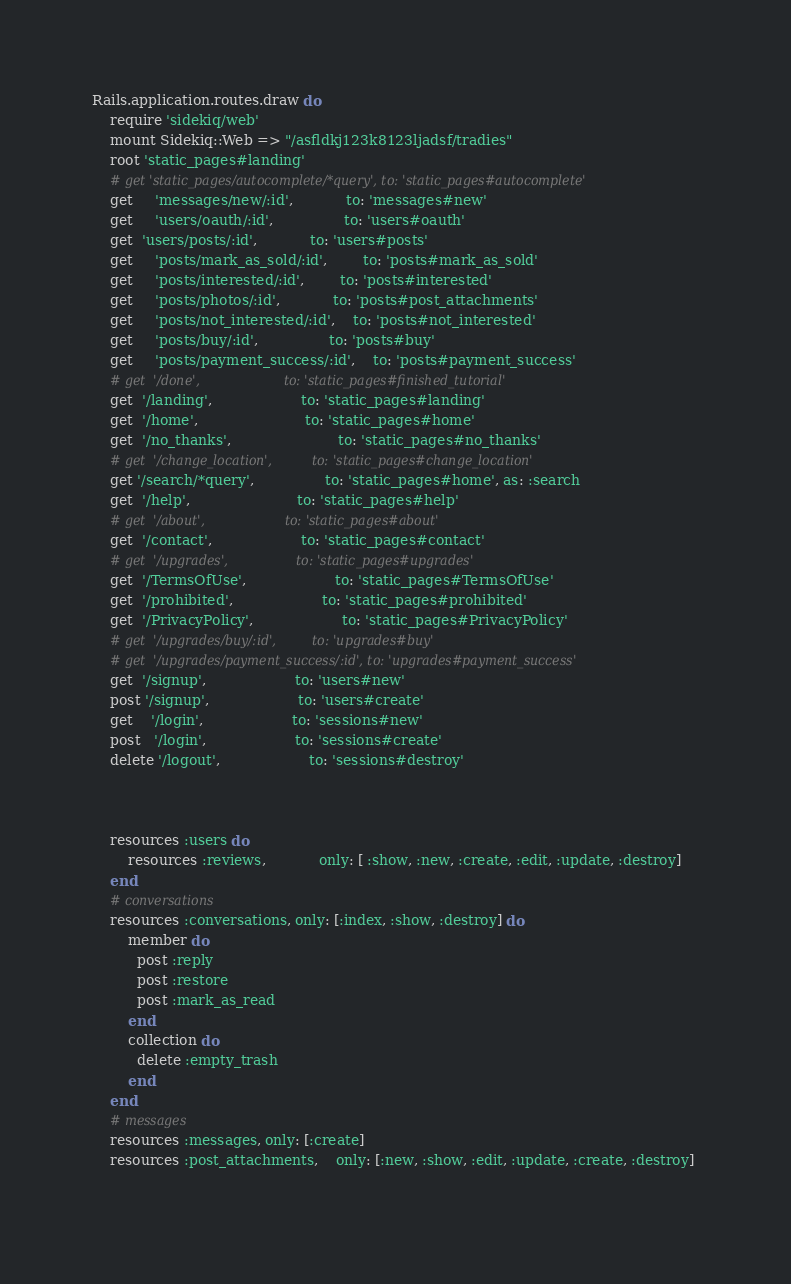<code> <loc_0><loc_0><loc_500><loc_500><_Ruby_>Rails.application.routes.draw do
	require 'sidekiq/web'
	mount Sidekiq::Web => "/asfldkj123k8123ljadsf/tradies"
	root 'static_pages#landing'
	# get 'static_pages/autocomplete/*query', to: 'static_pages#autocomplete'
	get	 'messages/new/:id',			to: 'messages#new' 
	get	 'users/oauth/:id',				to: 'users#oauth'
	get  'users/posts/:id', 			to: 'users#posts'
	get	 'posts/mark_as_sold/:id',		to: 'posts#mark_as_sold'
	get	 'posts/interested/:id',		to: 'posts#interested'
	get	 'posts/photos/:id',			to: 'posts#post_attachments'
	get	 'posts/not_interested/:id',	to: 'posts#not_interested'
	get	 'posts/buy/:id',				to: 'posts#buy'
	get	 'posts/payment_success/:id',	to: 'posts#payment_success'
	# get  '/done',    	 				to: 'static_pages#finished_tutorial'
	get  '/landing',    	 			to: 'static_pages#landing'
	get  '/home',    	 				to: 'static_pages#home'
	get  '/no_thanks',    	 				to: 'static_pages#no_thanks'
	# get  '/change_location',    	 	to: 'static_pages#change_location'
	get '/search/*query', 				to: 'static_pages#home', as: :search
	get  '/help',    	 				to: 'static_pages#help'
	# get  '/about',   	 				to: 'static_pages#about'
	get  '/contact',   					to: 'static_pages#contact'
	# get  '/upgrades',					to: 'static_pages#upgrades'
	get  '/TermsOfUse',					to: 'static_pages#TermsOfUse'
	get  '/prohibited',					to: 'static_pages#prohibited'
	get  '/PrivacyPolicy',					to: 'static_pages#PrivacyPolicy'
	# get  '/upgrades/buy/:id',			to: 'upgrades#buy'
	# get  '/upgrades/payment_success/:id',	to: 'upgrades#payment_success'
	get  '/signup',  	  				to: 'users#new'
	post '/signup', 					to: 'users#create'
	get    '/login',   					to: 'sessions#new'
	post   '/login',   					to: 'sessions#create'
	delete '/logout',  					to: 'sessions#destroy'



	resources :users do
		resources :reviews,  			only: [ :show, :new, :create, :edit, :update, :destroy]	
	end
	# conversations
	resources :conversations, only: [:index, :show, :destroy] do
    	member do
	      post :reply
	      post :restore
	      post :mark_as_read
	    end
	    collection do
	      delete :empty_trash
	    end
	end
	# messages
	resources :messages, only: [:create]
	resources :post_attachments, 	only: [:new, :show, :edit, :update, :create, :destroy]
	</code> 